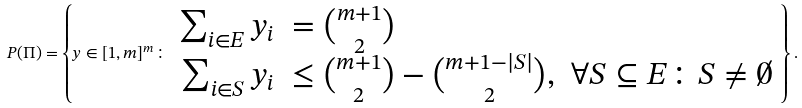<formula> <loc_0><loc_0><loc_500><loc_500>P ( \Pi ) = \left \{ y \in [ 1 , m ] ^ { m } \colon \begin{array} { r l c } \sum _ { i \in E } y _ { i } & = \binom { m + 1 } { 2 } & \\ \sum _ { i \in S } y _ { i } & \leq \binom { m + 1 } { 2 } - \binom { m + 1 - | S | } { 2 } , & \forall S \subseteq E \colon S \neq \emptyset \end{array} \right \} .</formula> 